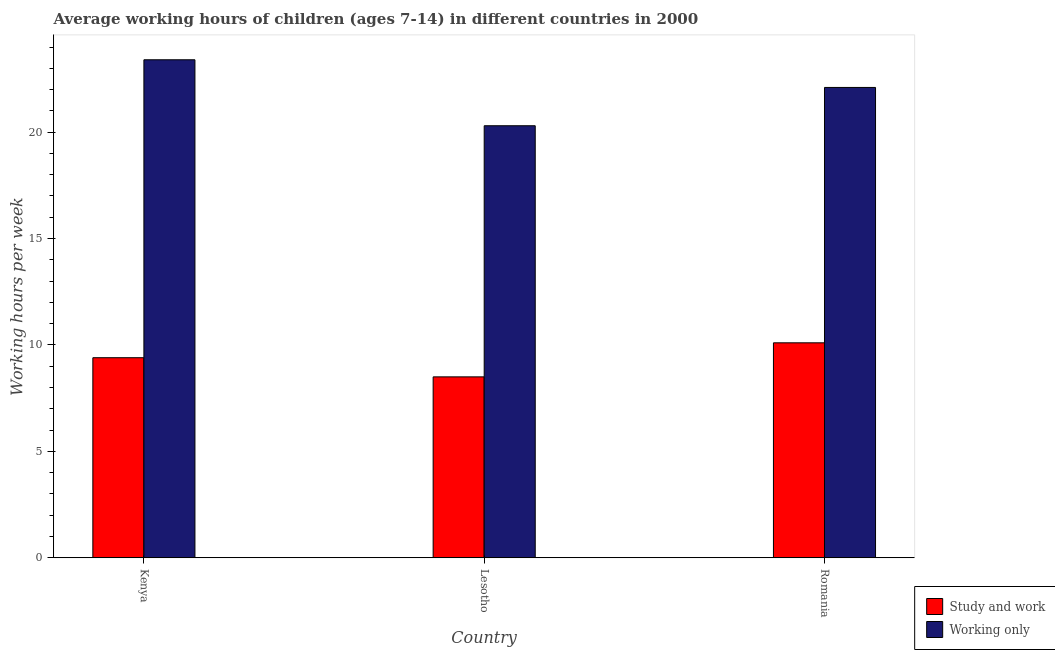How many groups of bars are there?
Keep it short and to the point. 3. How many bars are there on the 3rd tick from the left?
Make the answer very short. 2. How many bars are there on the 2nd tick from the right?
Provide a succinct answer. 2. What is the label of the 3rd group of bars from the left?
Offer a very short reply. Romania. In how many cases, is the number of bars for a given country not equal to the number of legend labels?
Give a very brief answer. 0. What is the average working hour of children involved in study and work in Lesotho?
Provide a succinct answer. 8.5. Across all countries, what is the maximum average working hour of children involved in only work?
Keep it short and to the point. 23.4. In which country was the average working hour of children involved in study and work maximum?
Offer a very short reply. Romania. In which country was the average working hour of children involved in study and work minimum?
Offer a very short reply. Lesotho. What is the total average working hour of children involved in study and work in the graph?
Give a very brief answer. 28. What is the difference between the average working hour of children involved in study and work in Kenya and that in Romania?
Offer a terse response. -0.7. What is the difference between the average working hour of children involved in only work in Lesotho and the average working hour of children involved in study and work in Kenya?
Keep it short and to the point. 10.9. What is the average average working hour of children involved in only work per country?
Provide a succinct answer. 21.93. What is the difference between the average working hour of children involved in only work and average working hour of children involved in study and work in Kenya?
Ensure brevity in your answer.  14. What is the ratio of the average working hour of children involved in only work in Lesotho to that in Romania?
Your answer should be compact. 0.92. What is the difference between the highest and the second highest average working hour of children involved in only work?
Offer a terse response. 1.3. What is the difference between the highest and the lowest average working hour of children involved in only work?
Make the answer very short. 3.1. In how many countries, is the average working hour of children involved in study and work greater than the average average working hour of children involved in study and work taken over all countries?
Ensure brevity in your answer.  2. Is the sum of the average working hour of children involved in only work in Kenya and Lesotho greater than the maximum average working hour of children involved in study and work across all countries?
Make the answer very short. Yes. What does the 1st bar from the left in Kenya represents?
Your answer should be compact. Study and work. What does the 2nd bar from the right in Lesotho represents?
Provide a short and direct response. Study and work. How many bars are there?
Keep it short and to the point. 6. Are all the bars in the graph horizontal?
Provide a short and direct response. No. How many countries are there in the graph?
Your answer should be compact. 3. What is the difference between two consecutive major ticks on the Y-axis?
Give a very brief answer. 5. Does the graph contain any zero values?
Your answer should be compact. No. Does the graph contain grids?
Your answer should be very brief. No. How many legend labels are there?
Your response must be concise. 2. What is the title of the graph?
Make the answer very short. Average working hours of children (ages 7-14) in different countries in 2000. Does "Forest" appear as one of the legend labels in the graph?
Your answer should be very brief. No. What is the label or title of the X-axis?
Provide a short and direct response. Country. What is the label or title of the Y-axis?
Offer a terse response. Working hours per week. What is the Working hours per week in Study and work in Kenya?
Keep it short and to the point. 9.4. What is the Working hours per week in Working only in Kenya?
Offer a very short reply. 23.4. What is the Working hours per week in Working only in Lesotho?
Provide a short and direct response. 20.3. What is the Working hours per week in Study and work in Romania?
Your answer should be compact. 10.1. What is the Working hours per week in Working only in Romania?
Keep it short and to the point. 22.1. Across all countries, what is the maximum Working hours per week in Working only?
Offer a terse response. 23.4. Across all countries, what is the minimum Working hours per week in Study and work?
Your answer should be very brief. 8.5. Across all countries, what is the minimum Working hours per week of Working only?
Your response must be concise. 20.3. What is the total Working hours per week of Working only in the graph?
Your answer should be compact. 65.8. What is the difference between the Working hours per week in Working only in Kenya and that in Lesotho?
Provide a short and direct response. 3.1. What is the difference between the Working hours per week of Study and work in Kenya and that in Romania?
Offer a very short reply. -0.7. What is the difference between the Working hours per week in Working only in Kenya and that in Romania?
Your answer should be compact. 1.3. What is the difference between the Working hours per week in Study and work in Lesotho and that in Romania?
Provide a short and direct response. -1.6. What is the difference between the Working hours per week in Working only in Lesotho and that in Romania?
Give a very brief answer. -1.8. What is the difference between the Working hours per week of Study and work in Kenya and the Working hours per week of Working only in Lesotho?
Your answer should be very brief. -10.9. What is the difference between the Working hours per week in Study and work in Kenya and the Working hours per week in Working only in Romania?
Provide a succinct answer. -12.7. What is the difference between the Working hours per week of Study and work in Lesotho and the Working hours per week of Working only in Romania?
Offer a very short reply. -13.6. What is the average Working hours per week in Study and work per country?
Offer a very short reply. 9.33. What is the average Working hours per week of Working only per country?
Make the answer very short. 21.93. What is the difference between the Working hours per week of Study and work and Working hours per week of Working only in Kenya?
Ensure brevity in your answer.  -14. What is the difference between the Working hours per week in Study and work and Working hours per week in Working only in Lesotho?
Provide a succinct answer. -11.8. What is the difference between the Working hours per week in Study and work and Working hours per week in Working only in Romania?
Offer a very short reply. -12. What is the ratio of the Working hours per week of Study and work in Kenya to that in Lesotho?
Make the answer very short. 1.11. What is the ratio of the Working hours per week of Working only in Kenya to that in Lesotho?
Provide a short and direct response. 1.15. What is the ratio of the Working hours per week of Study and work in Kenya to that in Romania?
Provide a succinct answer. 0.93. What is the ratio of the Working hours per week of Working only in Kenya to that in Romania?
Provide a succinct answer. 1.06. What is the ratio of the Working hours per week in Study and work in Lesotho to that in Romania?
Make the answer very short. 0.84. What is the ratio of the Working hours per week in Working only in Lesotho to that in Romania?
Your answer should be very brief. 0.92. What is the difference between the highest and the lowest Working hours per week in Study and work?
Your response must be concise. 1.6. 